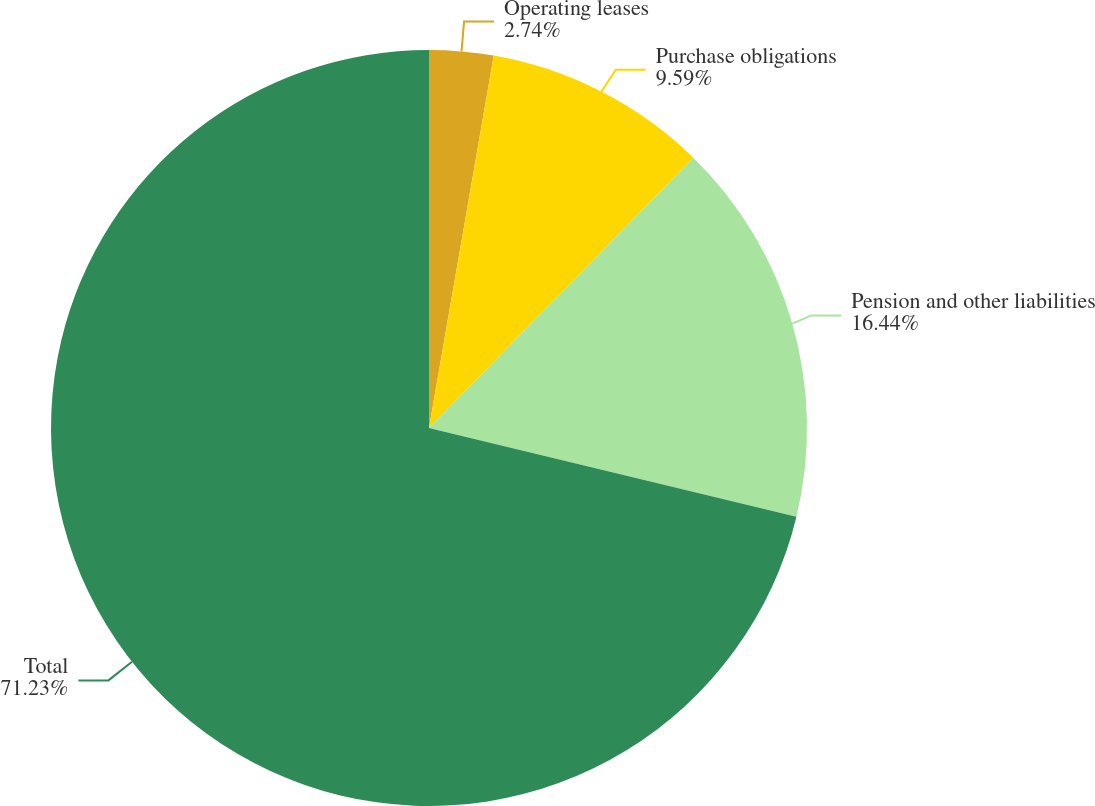Convert chart. <chart><loc_0><loc_0><loc_500><loc_500><pie_chart><fcel>Operating leases<fcel>Purchase obligations<fcel>Pension and other liabilities<fcel>Total<nl><fcel>2.74%<fcel>9.59%<fcel>16.44%<fcel>71.23%<nl></chart> 